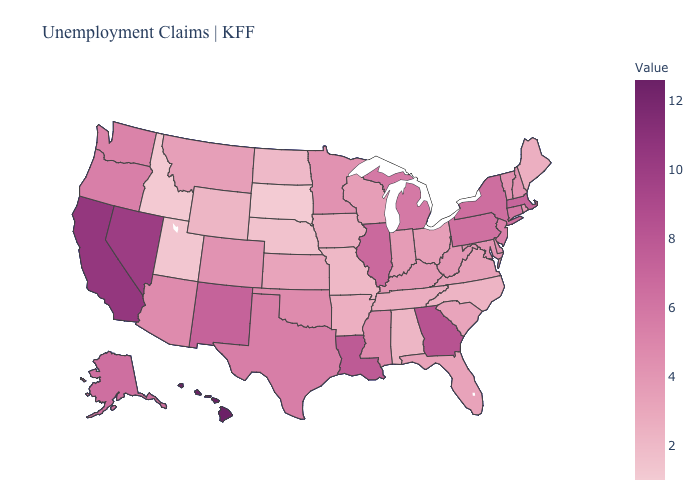Which states have the lowest value in the West?
Answer briefly. Idaho. Among the states that border Delaware , does Maryland have the highest value?
Write a very short answer. No. Among the states that border Connecticut , does Rhode Island have the lowest value?
Write a very short answer. Yes. Which states have the highest value in the USA?
Give a very brief answer. Hawaii. Is the legend a continuous bar?
Be succinct. Yes. Which states have the highest value in the USA?
Short answer required. Hawaii. 